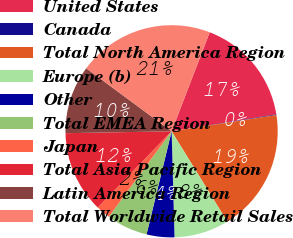Convert chart to OTSL. <chart><loc_0><loc_0><loc_500><loc_500><pie_chart><fcel>United States<fcel>Canada<fcel>Total North America Region<fcel>Europe (b)<fcel>Other<fcel>Total EMEA Region<fcel>Japan<fcel>Total Asia Pacific Region<fcel>Latin America Region<fcel>Total Worldwide Retail Sales<nl><fcel>16.6%<fcel>0.1%<fcel>18.66%<fcel>8.35%<fcel>4.23%<fcel>6.29%<fcel>2.16%<fcel>12.47%<fcel>10.41%<fcel>20.72%<nl></chart> 